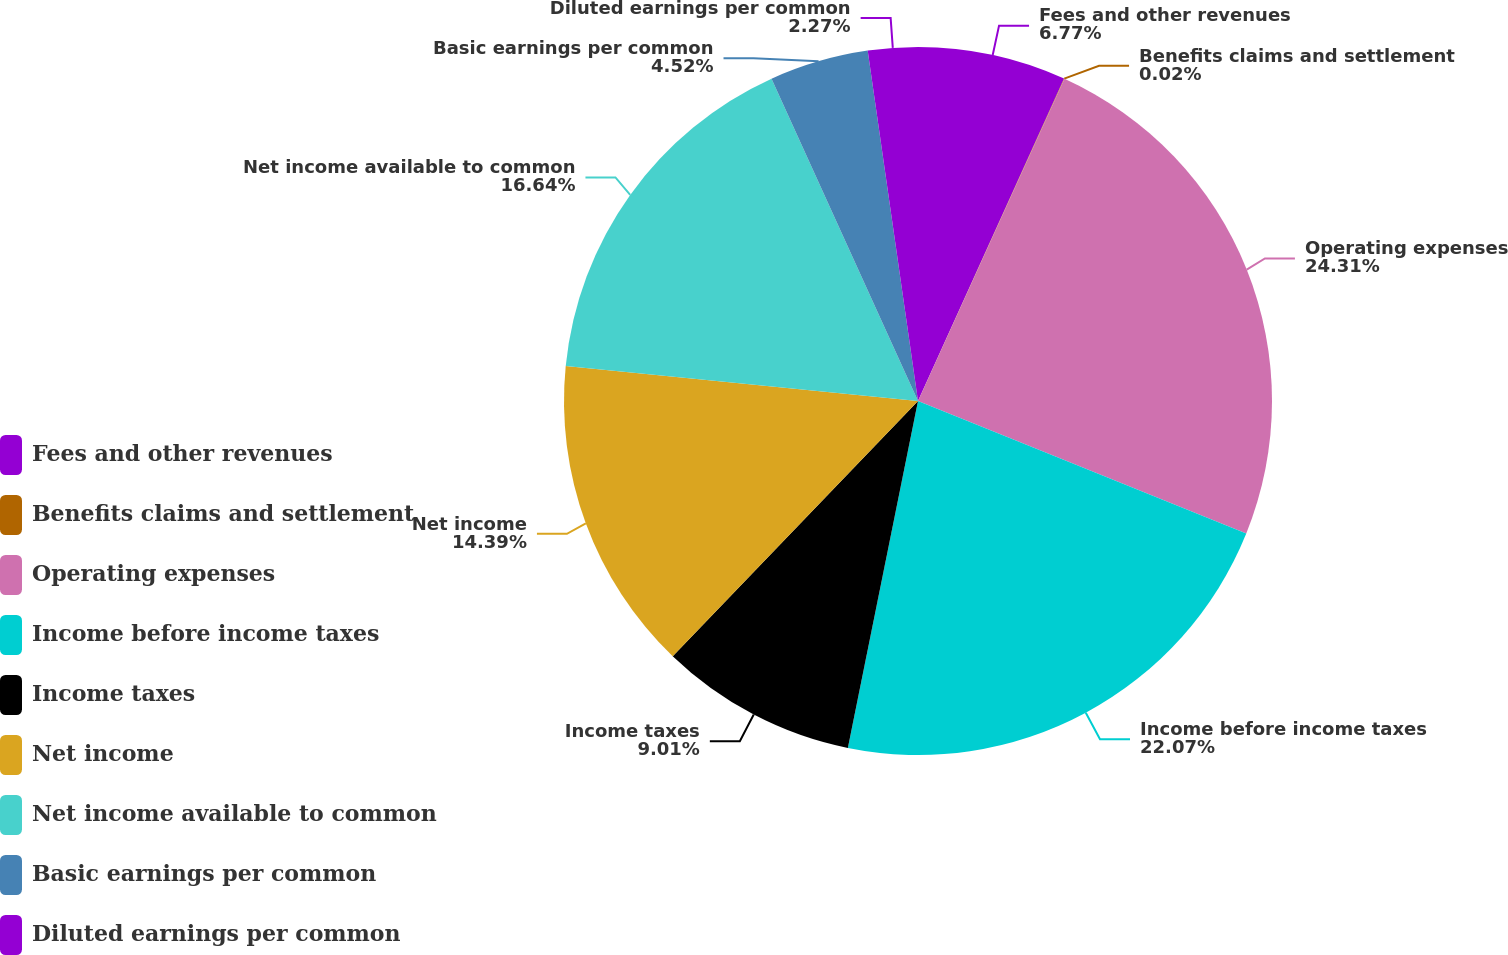Convert chart to OTSL. <chart><loc_0><loc_0><loc_500><loc_500><pie_chart><fcel>Fees and other revenues<fcel>Benefits claims and settlement<fcel>Operating expenses<fcel>Income before income taxes<fcel>Income taxes<fcel>Net income<fcel>Net income available to common<fcel>Basic earnings per common<fcel>Diluted earnings per common<nl><fcel>6.77%<fcel>0.02%<fcel>24.32%<fcel>22.07%<fcel>9.01%<fcel>14.39%<fcel>16.64%<fcel>4.52%<fcel>2.27%<nl></chart> 